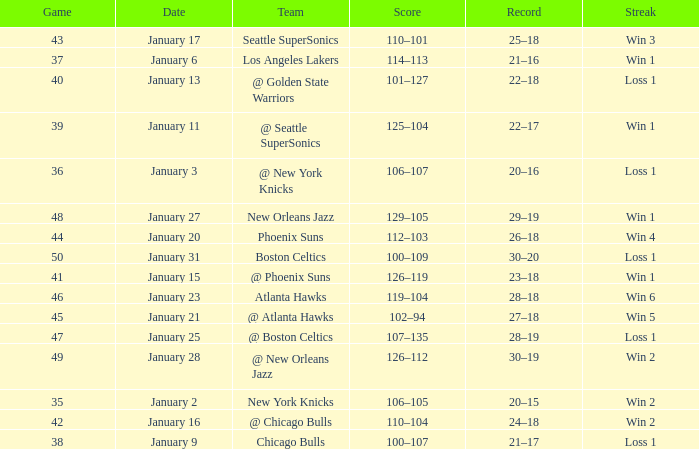What is the Streak in the game with a Record of 20–16? Loss 1. 